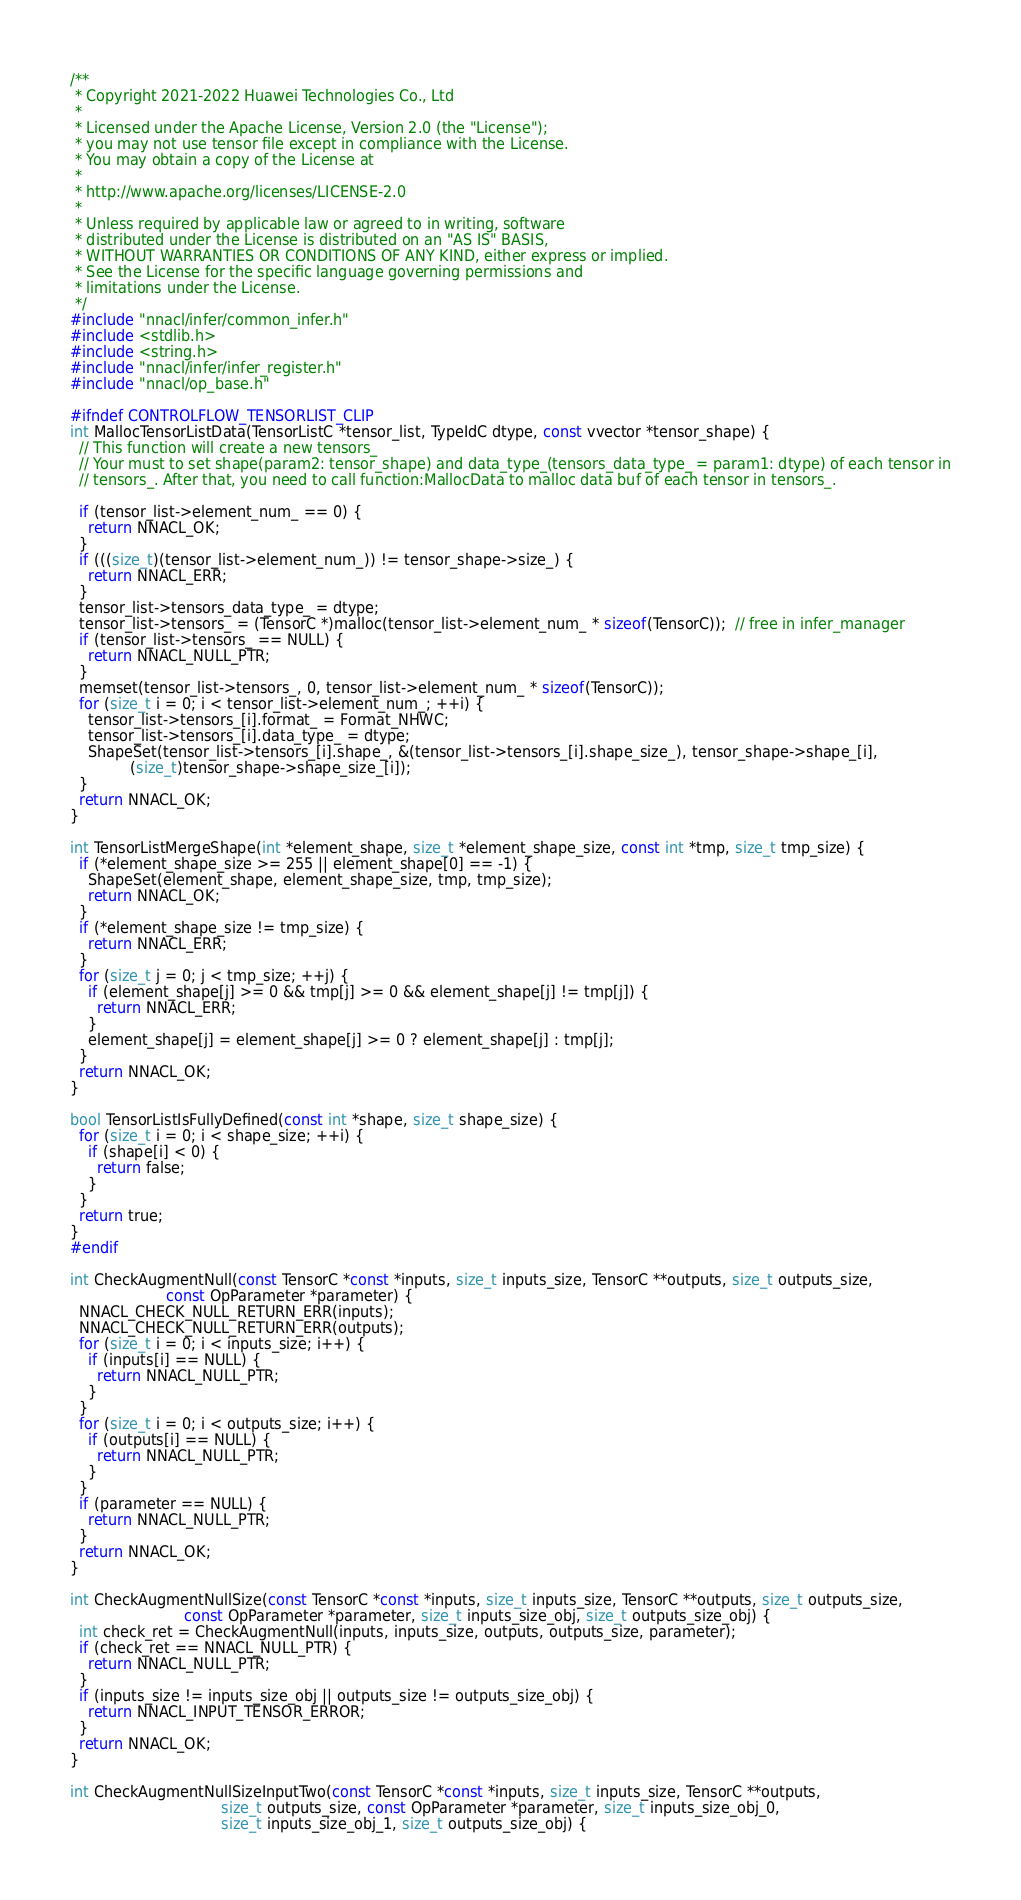<code> <loc_0><loc_0><loc_500><loc_500><_C_>/**
 * Copyright 2021-2022 Huawei Technologies Co., Ltd
 *
 * Licensed under the Apache License, Version 2.0 (the "License");
 * you may not use tensor file except in compliance with the License.
 * You may obtain a copy of the License at
 *
 * http://www.apache.org/licenses/LICENSE-2.0
 *
 * Unless required by applicable law or agreed to in writing, software
 * distributed under the License is distributed on an "AS IS" BASIS,
 * WITHOUT WARRANTIES OR CONDITIONS OF ANY KIND, either express or implied.
 * See the License for the specific language governing permissions and
 * limitations under the License.
 */
#include "nnacl/infer/common_infer.h"
#include <stdlib.h>
#include <string.h>
#include "nnacl/infer/infer_register.h"
#include "nnacl/op_base.h"

#ifndef CONTROLFLOW_TENSORLIST_CLIP
int MallocTensorListData(TensorListC *tensor_list, TypeIdC dtype, const vvector *tensor_shape) {
  // This function will create a new tensors_
  // Your must to set shape(param2: tensor_shape) and data_type_(tensors_data_type_ = param1: dtype) of each tensor in
  // tensors_. After that, you need to call function:MallocData to malloc data buf of each tensor in tensors_.

  if (tensor_list->element_num_ == 0) {
    return NNACL_OK;
  }
  if (((size_t)(tensor_list->element_num_)) != tensor_shape->size_) {
    return NNACL_ERR;
  }
  tensor_list->tensors_data_type_ = dtype;
  tensor_list->tensors_ = (TensorC *)malloc(tensor_list->element_num_ * sizeof(TensorC));  // free in infer_manager
  if (tensor_list->tensors_ == NULL) {
    return NNACL_NULL_PTR;
  }
  memset(tensor_list->tensors_, 0, tensor_list->element_num_ * sizeof(TensorC));
  for (size_t i = 0; i < tensor_list->element_num_; ++i) {
    tensor_list->tensors_[i].format_ = Format_NHWC;
    tensor_list->tensors_[i].data_type_ = dtype;
    ShapeSet(tensor_list->tensors_[i].shape_, &(tensor_list->tensors_[i].shape_size_), tensor_shape->shape_[i],
             (size_t)tensor_shape->shape_size_[i]);
  }
  return NNACL_OK;
}

int TensorListMergeShape(int *element_shape, size_t *element_shape_size, const int *tmp, size_t tmp_size) {
  if (*element_shape_size >= 255 || element_shape[0] == -1) {
    ShapeSet(element_shape, element_shape_size, tmp, tmp_size);
    return NNACL_OK;
  }
  if (*element_shape_size != tmp_size) {
    return NNACL_ERR;
  }
  for (size_t j = 0; j < tmp_size; ++j) {
    if (element_shape[j] >= 0 && tmp[j] >= 0 && element_shape[j] != tmp[j]) {
      return NNACL_ERR;
    }
    element_shape[j] = element_shape[j] >= 0 ? element_shape[j] : tmp[j];
  }
  return NNACL_OK;
}

bool TensorListIsFullyDefined(const int *shape, size_t shape_size) {
  for (size_t i = 0; i < shape_size; ++i) {
    if (shape[i] < 0) {
      return false;
    }
  }
  return true;
}
#endif

int CheckAugmentNull(const TensorC *const *inputs, size_t inputs_size, TensorC **outputs, size_t outputs_size,
                     const OpParameter *parameter) {
  NNACL_CHECK_NULL_RETURN_ERR(inputs);
  NNACL_CHECK_NULL_RETURN_ERR(outputs);
  for (size_t i = 0; i < inputs_size; i++) {
    if (inputs[i] == NULL) {
      return NNACL_NULL_PTR;
    }
  }
  for (size_t i = 0; i < outputs_size; i++) {
    if (outputs[i] == NULL) {
      return NNACL_NULL_PTR;
    }
  }
  if (parameter == NULL) {
    return NNACL_NULL_PTR;
  }
  return NNACL_OK;
}

int CheckAugmentNullSize(const TensorC *const *inputs, size_t inputs_size, TensorC **outputs, size_t outputs_size,
                         const OpParameter *parameter, size_t inputs_size_obj, size_t outputs_size_obj) {
  int check_ret = CheckAugmentNull(inputs, inputs_size, outputs, outputs_size, parameter);
  if (check_ret == NNACL_NULL_PTR) {
    return NNACL_NULL_PTR;
  }
  if (inputs_size != inputs_size_obj || outputs_size != outputs_size_obj) {
    return NNACL_INPUT_TENSOR_ERROR;
  }
  return NNACL_OK;
}

int CheckAugmentNullSizeInputTwo(const TensorC *const *inputs, size_t inputs_size, TensorC **outputs,
                                 size_t outputs_size, const OpParameter *parameter, size_t inputs_size_obj_0,
                                 size_t inputs_size_obj_1, size_t outputs_size_obj) {</code> 